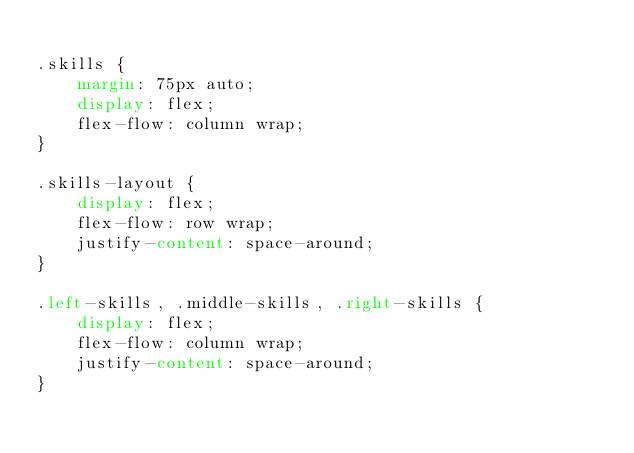<code> <loc_0><loc_0><loc_500><loc_500><_CSS_>
.skills {
	margin: 75px auto;
	display: flex;
	flex-flow: column wrap;
}

.skills-layout {
	display: flex;
	flex-flow: row wrap;
	justify-content: space-around;
}

.left-skills, .middle-skills, .right-skills {
	display: flex;
	flex-flow: column wrap;	
	justify-content: space-around;
}</code> 